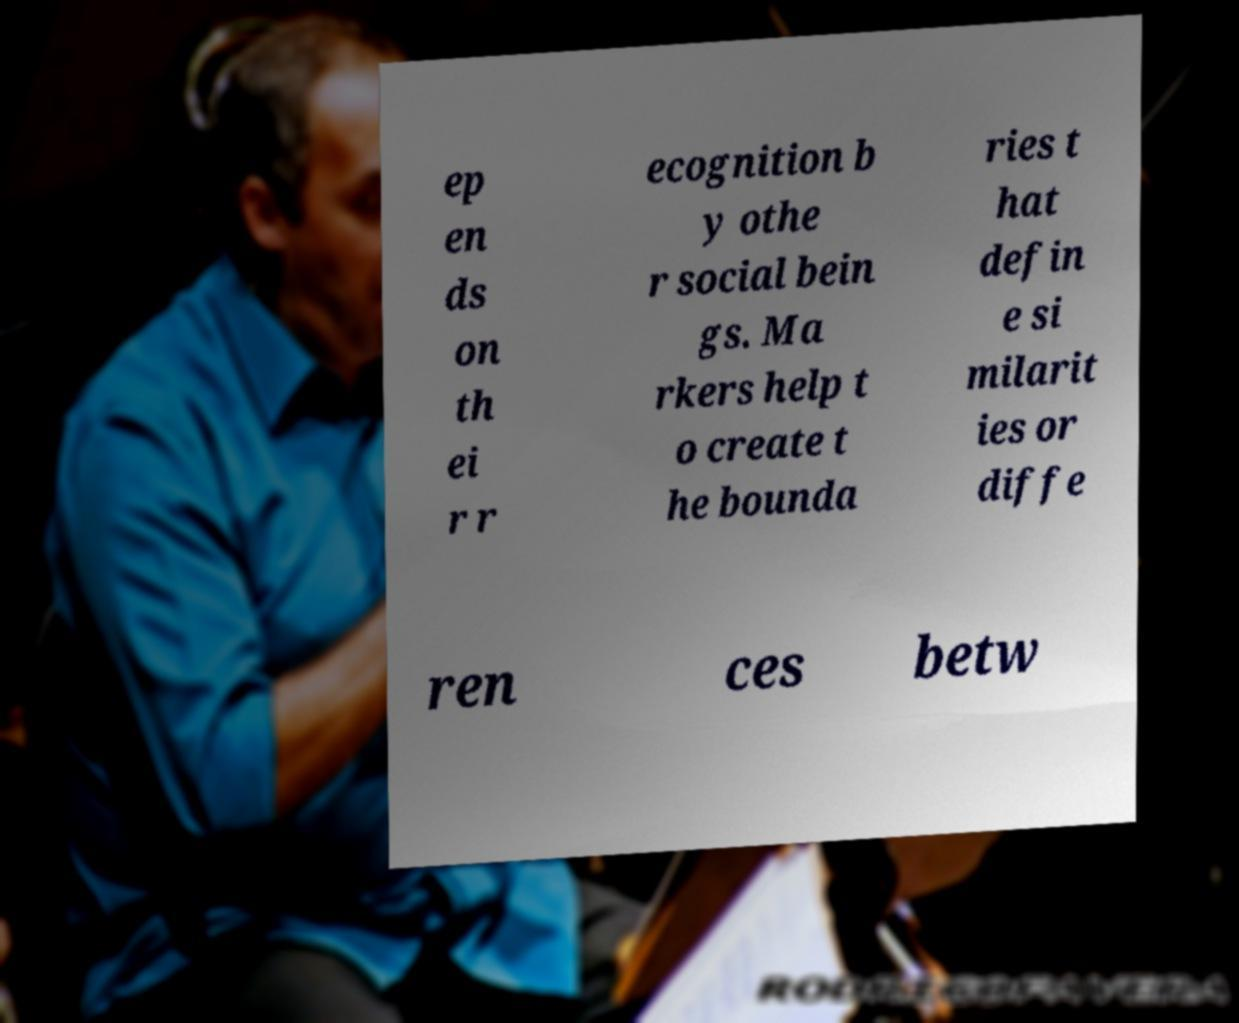Please identify and transcribe the text found in this image. ep en ds on th ei r r ecognition b y othe r social bein gs. Ma rkers help t o create t he bounda ries t hat defin e si milarit ies or diffe ren ces betw 